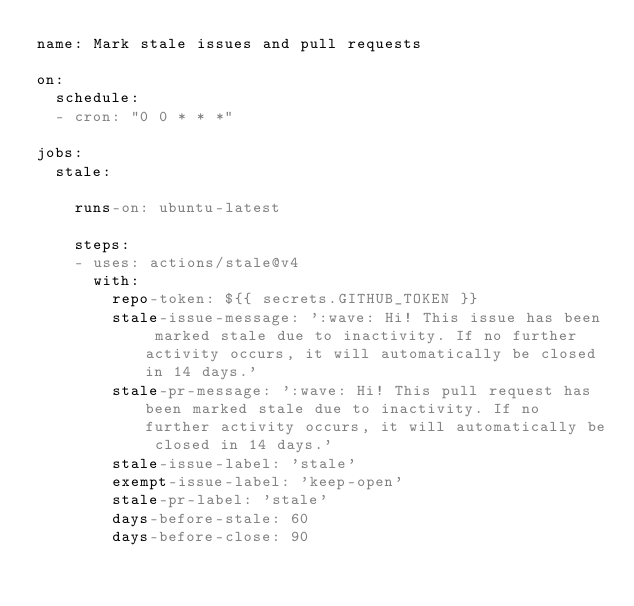Convert code to text. <code><loc_0><loc_0><loc_500><loc_500><_YAML_>name: Mark stale issues and pull requests

on:
  schedule:
  - cron: "0 0 * * *"

jobs:
  stale:

    runs-on: ubuntu-latest

    steps:
    - uses: actions/stale@v4
      with:
        repo-token: ${{ secrets.GITHUB_TOKEN }}
        stale-issue-message: ':wave: Hi! This issue has been marked stale due to inactivity. If no further activity occurs, it will automatically be closed in 14 days.'
        stale-pr-message: ':wave: Hi! This pull request has been marked stale due to inactivity. If no further activity occurs, it will automatically be closed in 14 days.'
        stale-issue-label: 'stale'
        exempt-issue-label: 'keep-open'
        stale-pr-label: 'stale'
        days-before-stale: 60
        days-before-close: 90
</code> 